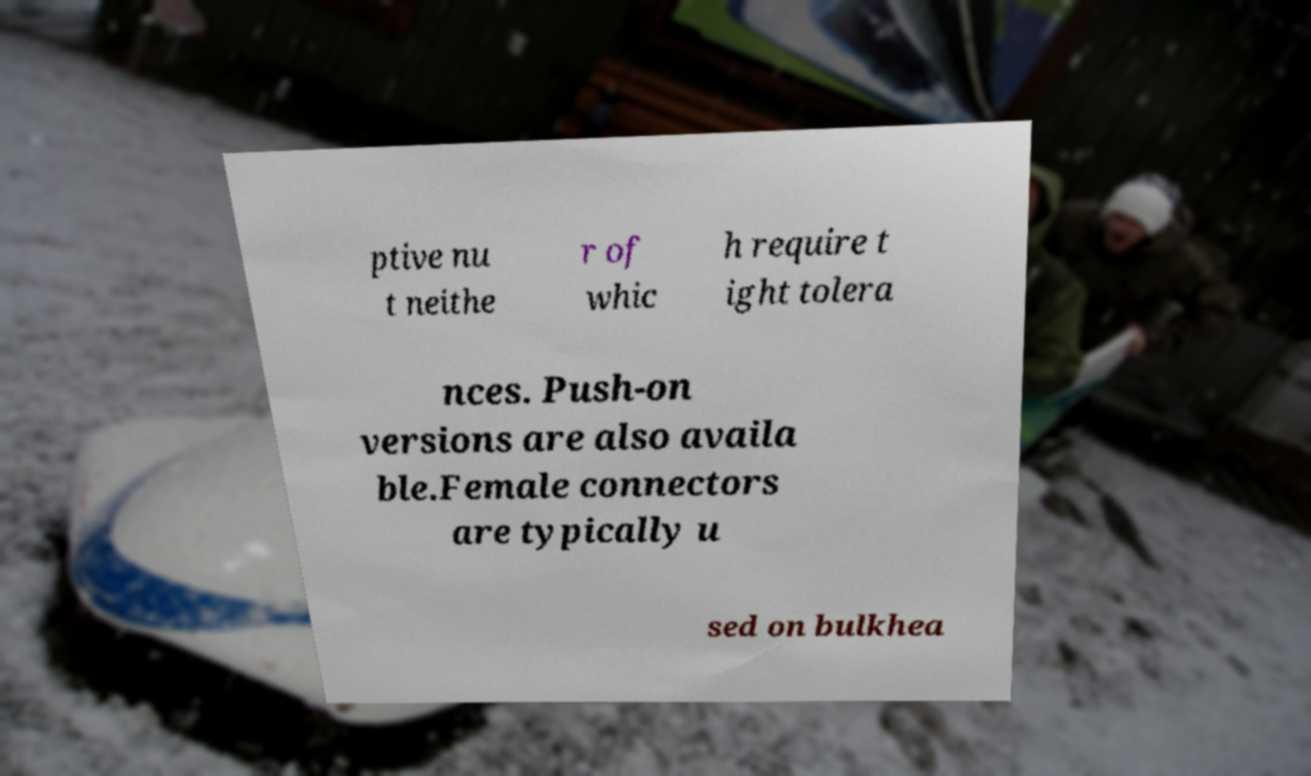Can you accurately transcribe the text from the provided image for me? ptive nu t neithe r of whic h require t ight tolera nces. Push-on versions are also availa ble.Female connectors are typically u sed on bulkhea 